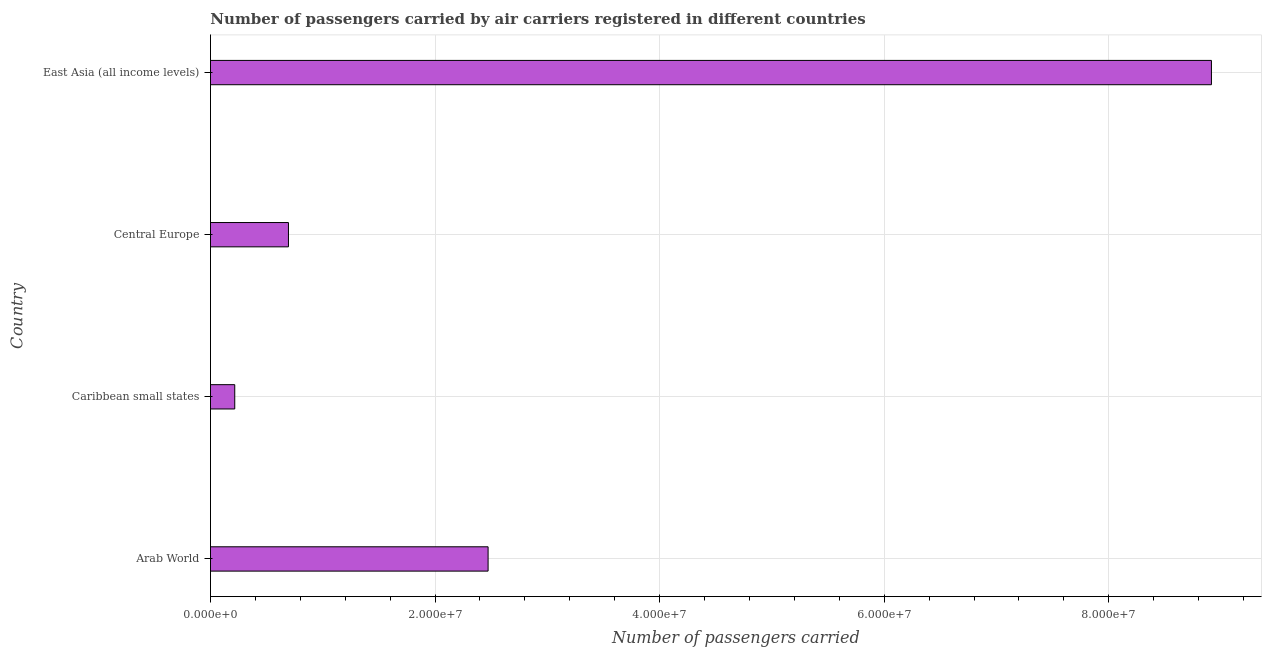Does the graph contain grids?
Make the answer very short. Yes. What is the title of the graph?
Your answer should be compact. Number of passengers carried by air carriers registered in different countries. What is the label or title of the X-axis?
Give a very brief answer. Number of passengers carried. What is the number of passengers carried in Arab World?
Provide a succinct answer. 2.47e+07. Across all countries, what is the maximum number of passengers carried?
Your response must be concise. 8.91e+07. Across all countries, what is the minimum number of passengers carried?
Provide a succinct answer. 2.16e+06. In which country was the number of passengers carried maximum?
Keep it short and to the point. East Asia (all income levels). In which country was the number of passengers carried minimum?
Your answer should be very brief. Caribbean small states. What is the sum of the number of passengers carried?
Your answer should be very brief. 1.23e+08. What is the difference between the number of passengers carried in Caribbean small states and Central Europe?
Offer a very short reply. -4.78e+06. What is the average number of passengers carried per country?
Keep it short and to the point. 3.07e+07. What is the median number of passengers carried?
Give a very brief answer. 1.58e+07. What is the ratio of the number of passengers carried in Arab World to that in Central Europe?
Provide a succinct answer. 3.56. What is the difference between the highest and the second highest number of passengers carried?
Provide a short and direct response. 6.44e+07. Is the sum of the number of passengers carried in Central Europe and East Asia (all income levels) greater than the maximum number of passengers carried across all countries?
Keep it short and to the point. Yes. What is the difference between the highest and the lowest number of passengers carried?
Your response must be concise. 8.70e+07. Are all the bars in the graph horizontal?
Offer a terse response. Yes. What is the difference between two consecutive major ticks on the X-axis?
Your response must be concise. 2.00e+07. What is the Number of passengers carried of Arab World?
Provide a short and direct response. 2.47e+07. What is the Number of passengers carried in Caribbean small states?
Your answer should be very brief. 2.16e+06. What is the Number of passengers carried of Central Europe?
Your answer should be compact. 6.95e+06. What is the Number of passengers carried in East Asia (all income levels)?
Give a very brief answer. 8.91e+07. What is the difference between the Number of passengers carried in Arab World and Caribbean small states?
Give a very brief answer. 2.26e+07. What is the difference between the Number of passengers carried in Arab World and Central Europe?
Ensure brevity in your answer.  1.78e+07. What is the difference between the Number of passengers carried in Arab World and East Asia (all income levels)?
Ensure brevity in your answer.  -6.44e+07. What is the difference between the Number of passengers carried in Caribbean small states and Central Europe?
Keep it short and to the point. -4.78e+06. What is the difference between the Number of passengers carried in Caribbean small states and East Asia (all income levels)?
Your response must be concise. -8.70e+07. What is the difference between the Number of passengers carried in Central Europe and East Asia (all income levels)?
Provide a succinct answer. -8.22e+07. What is the ratio of the Number of passengers carried in Arab World to that in Caribbean small states?
Make the answer very short. 11.44. What is the ratio of the Number of passengers carried in Arab World to that in Central Europe?
Offer a terse response. 3.56. What is the ratio of the Number of passengers carried in Arab World to that in East Asia (all income levels)?
Offer a terse response. 0.28. What is the ratio of the Number of passengers carried in Caribbean small states to that in Central Europe?
Offer a very short reply. 0.31. What is the ratio of the Number of passengers carried in Caribbean small states to that in East Asia (all income levels)?
Your answer should be compact. 0.02. What is the ratio of the Number of passengers carried in Central Europe to that in East Asia (all income levels)?
Ensure brevity in your answer.  0.08. 